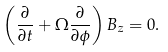<formula> <loc_0><loc_0><loc_500><loc_500>\left ( \frac { \partial } { \partial t } + \Omega \frac { \partial } { \partial \phi } \right ) B _ { z } = 0 .</formula> 